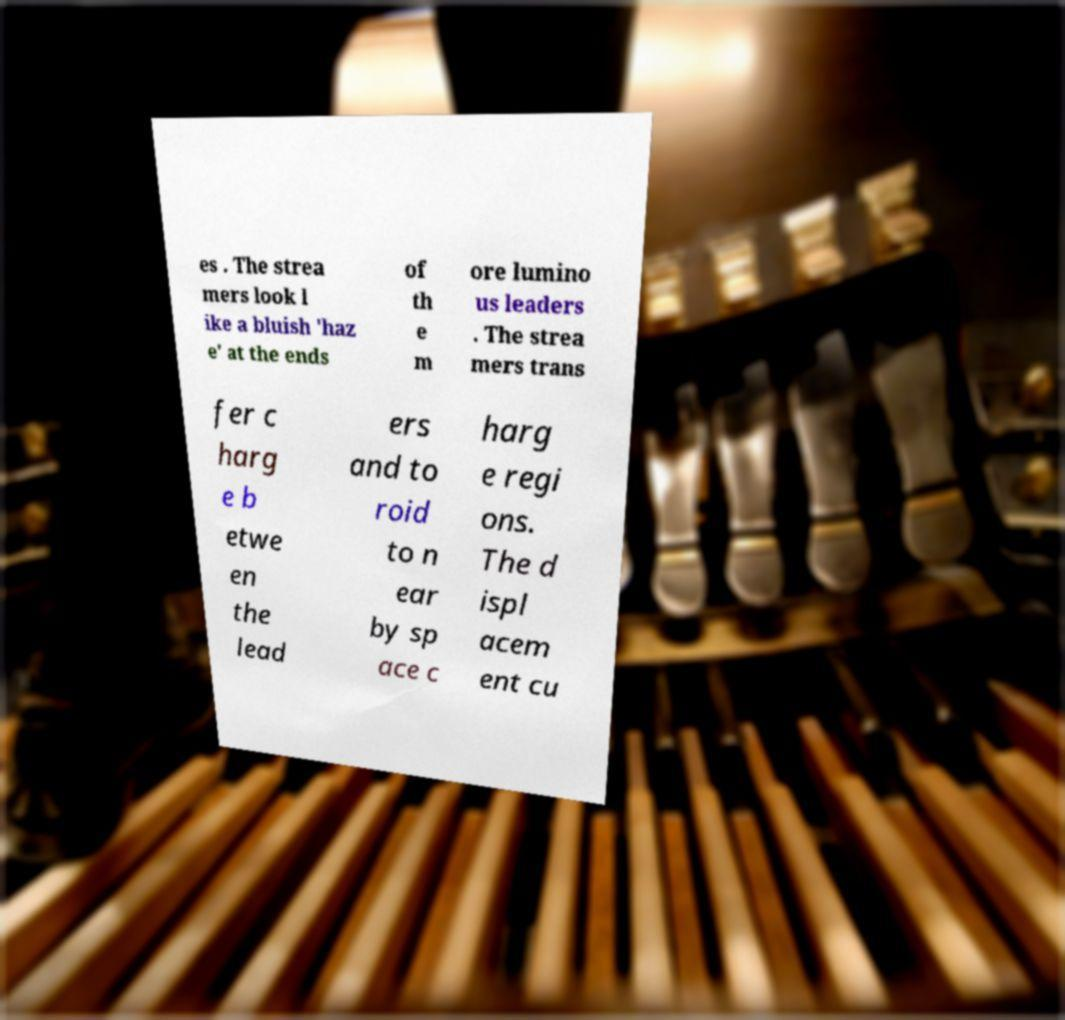Can you accurately transcribe the text from the provided image for me? es . The strea mers look l ike a bluish 'haz e' at the ends of th e m ore lumino us leaders . The strea mers trans fer c harg e b etwe en the lead ers and to roid to n ear by sp ace c harg e regi ons. The d ispl acem ent cu 